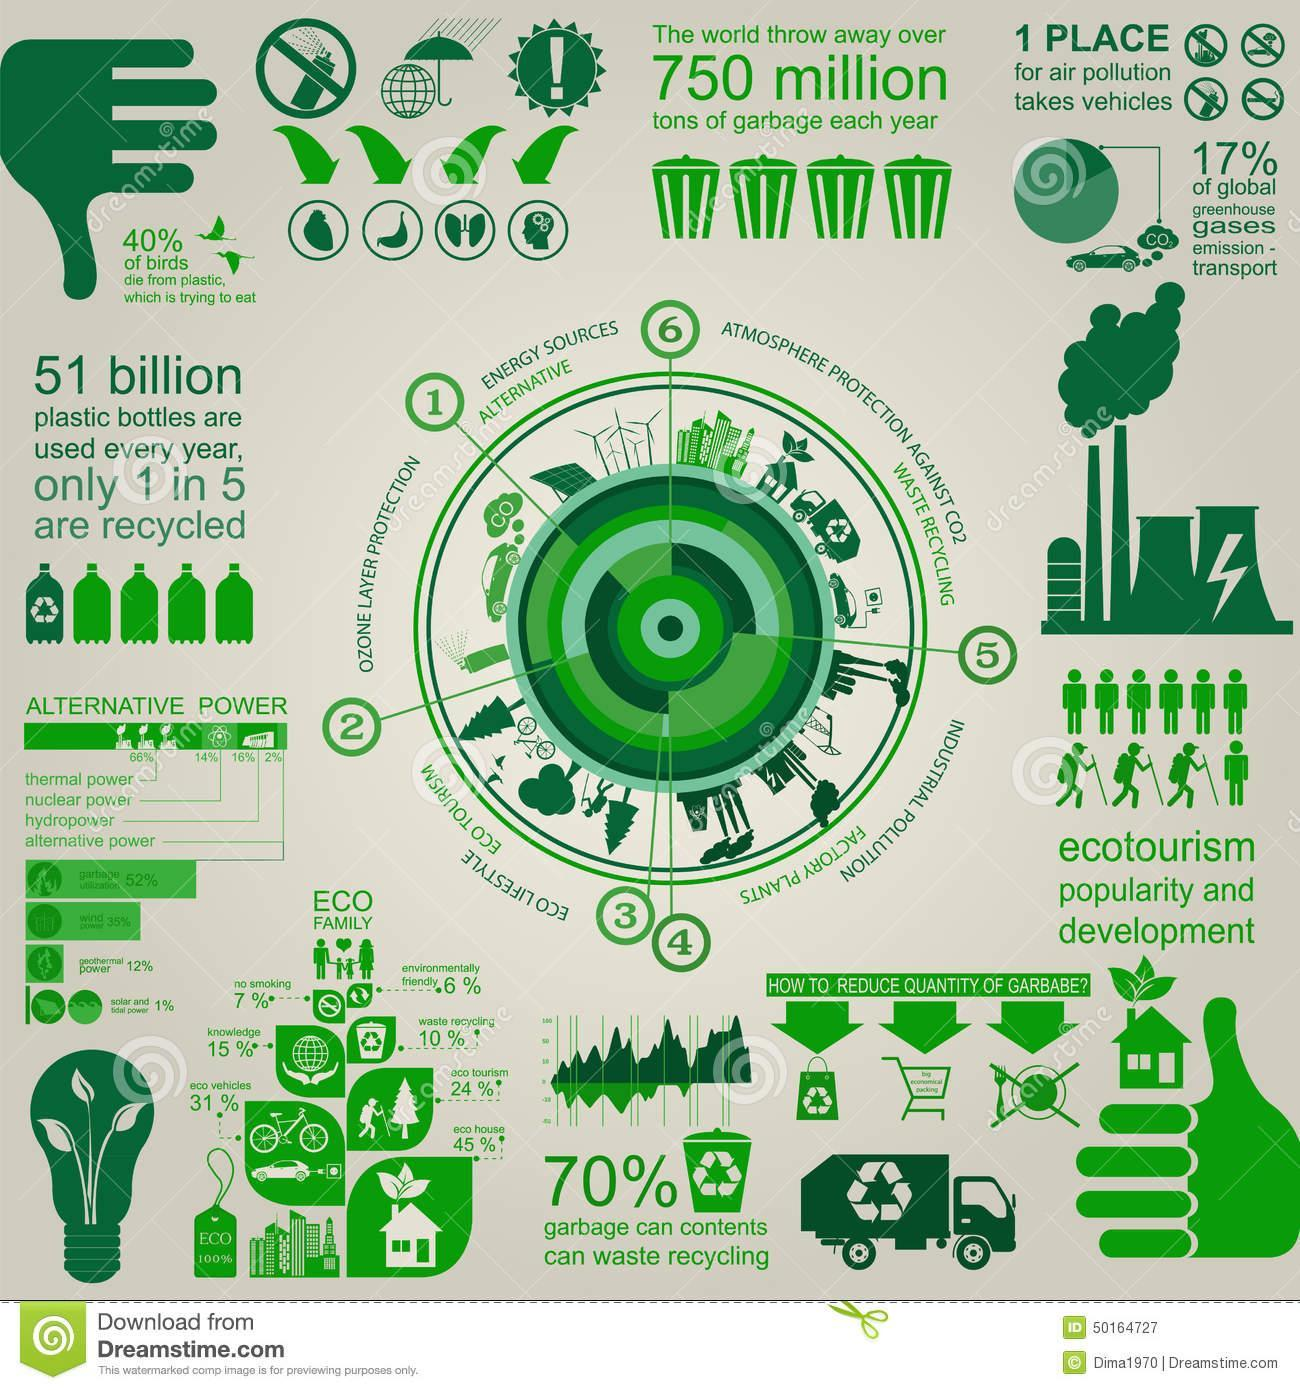What percentage of eco-house and eco-tourism together constitute the eco-family?
Answer the question with a short phrase. 69% What percentage of hydro and alternative power together constitute the total power? 18% Out of 5, how many bottles  not recycled? 4 What percentage of eco-vehicles and knowledge together constitute the eco-family? 46% What percentage of thermal and nuclear power together constitute the total power? 80% What percentage of birds die not from plastic? 60% 